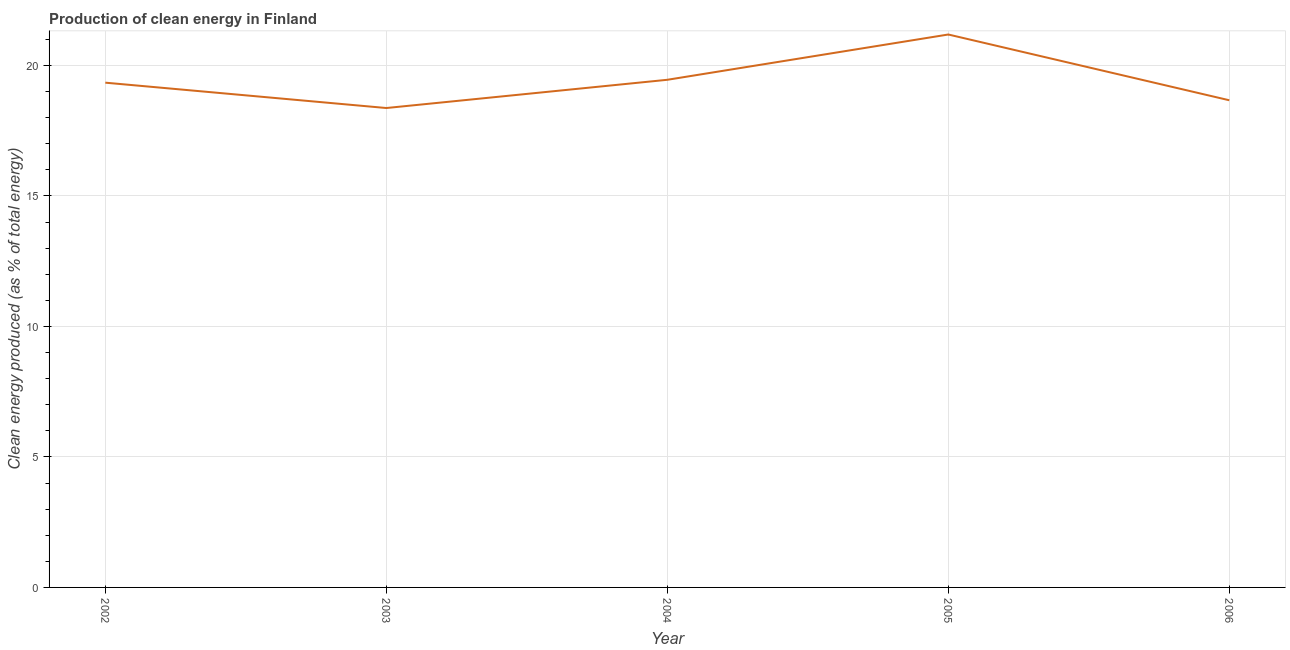What is the production of clean energy in 2005?
Provide a succinct answer. 21.19. Across all years, what is the maximum production of clean energy?
Your answer should be very brief. 21.19. Across all years, what is the minimum production of clean energy?
Make the answer very short. 18.37. In which year was the production of clean energy minimum?
Ensure brevity in your answer.  2003. What is the sum of the production of clean energy?
Make the answer very short. 97.01. What is the difference between the production of clean energy in 2002 and 2006?
Make the answer very short. 0.67. What is the average production of clean energy per year?
Ensure brevity in your answer.  19.4. What is the median production of clean energy?
Ensure brevity in your answer.  19.34. In how many years, is the production of clean energy greater than 18 %?
Keep it short and to the point. 5. Do a majority of the years between 2006 and 2002 (inclusive) have production of clean energy greater than 15 %?
Make the answer very short. Yes. What is the ratio of the production of clean energy in 2003 to that in 2006?
Your answer should be compact. 0.98. What is the difference between the highest and the second highest production of clean energy?
Provide a succinct answer. 1.74. Is the sum of the production of clean energy in 2003 and 2005 greater than the maximum production of clean energy across all years?
Your answer should be compact. Yes. What is the difference between the highest and the lowest production of clean energy?
Offer a terse response. 2.82. Are the values on the major ticks of Y-axis written in scientific E-notation?
Offer a very short reply. No. Does the graph contain grids?
Your response must be concise. Yes. What is the title of the graph?
Offer a very short reply. Production of clean energy in Finland. What is the label or title of the Y-axis?
Your response must be concise. Clean energy produced (as % of total energy). What is the Clean energy produced (as % of total energy) in 2002?
Give a very brief answer. 19.34. What is the Clean energy produced (as % of total energy) in 2003?
Provide a succinct answer. 18.37. What is the Clean energy produced (as % of total energy) in 2004?
Provide a short and direct response. 19.45. What is the Clean energy produced (as % of total energy) in 2005?
Give a very brief answer. 21.19. What is the Clean energy produced (as % of total energy) in 2006?
Your answer should be compact. 18.67. What is the difference between the Clean energy produced (as % of total energy) in 2002 and 2003?
Make the answer very short. 0.97. What is the difference between the Clean energy produced (as % of total energy) in 2002 and 2004?
Provide a short and direct response. -0.11. What is the difference between the Clean energy produced (as % of total energy) in 2002 and 2005?
Provide a succinct answer. -1.85. What is the difference between the Clean energy produced (as % of total energy) in 2002 and 2006?
Provide a succinct answer. 0.67. What is the difference between the Clean energy produced (as % of total energy) in 2003 and 2004?
Ensure brevity in your answer.  -1.08. What is the difference between the Clean energy produced (as % of total energy) in 2003 and 2005?
Ensure brevity in your answer.  -2.82. What is the difference between the Clean energy produced (as % of total energy) in 2003 and 2006?
Your response must be concise. -0.3. What is the difference between the Clean energy produced (as % of total energy) in 2004 and 2005?
Make the answer very short. -1.74. What is the difference between the Clean energy produced (as % of total energy) in 2004 and 2006?
Your response must be concise. 0.78. What is the difference between the Clean energy produced (as % of total energy) in 2005 and 2006?
Provide a short and direct response. 2.52. What is the ratio of the Clean energy produced (as % of total energy) in 2002 to that in 2003?
Provide a succinct answer. 1.05. What is the ratio of the Clean energy produced (as % of total energy) in 2002 to that in 2006?
Provide a short and direct response. 1.04. What is the ratio of the Clean energy produced (as % of total energy) in 2003 to that in 2004?
Offer a very short reply. 0.94. What is the ratio of the Clean energy produced (as % of total energy) in 2003 to that in 2005?
Your answer should be compact. 0.87. What is the ratio of the Clean energy produced (as % of total energy) in 2003 to that in 2006?
Keep it short and to the point. 0.98. What is the ratio of the Clean energy produced (as % of total energy) in 2004 to that in 2005?
Make the answer very short. 0.92. What is the ratio of the Clean energy produced (as % of total energy) in 2004 to that in 2006?
Your response must be concise. 1.04. What is the ratio of the Clean energy produced (as % of total energy) in 2005 to that in 2006?
Ensure brevity in your answer.  1.14. 